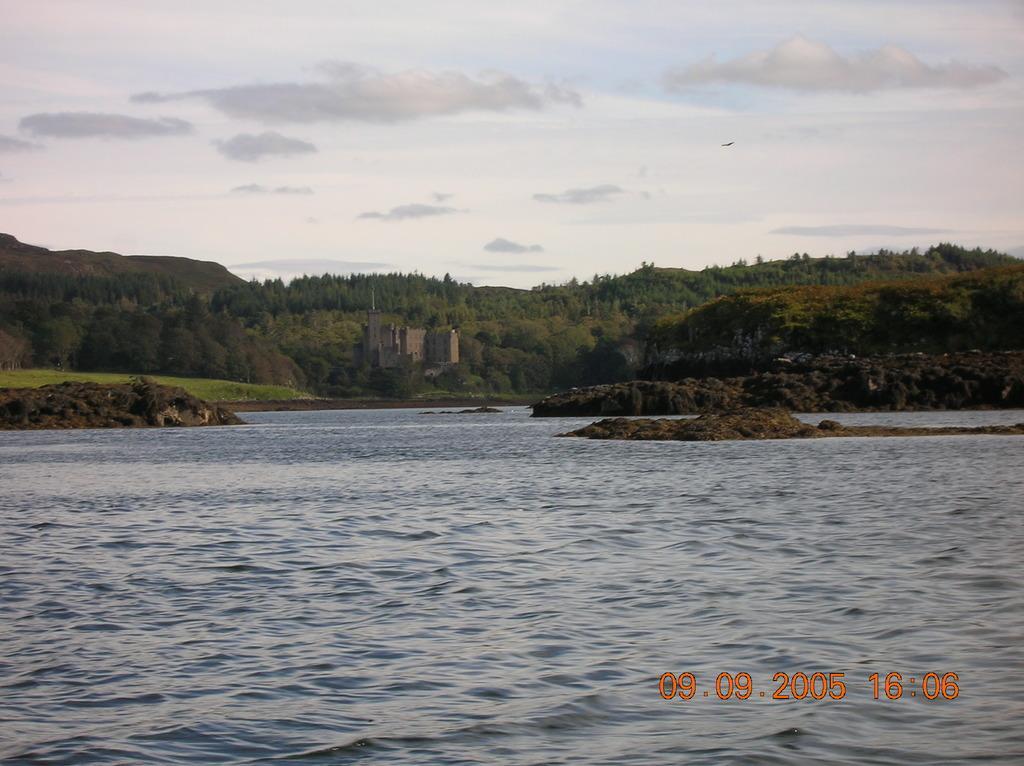In one or two sentences, can you explain what this image depicts? In this image we can see water, building, trees, hills, sky and clouds. 